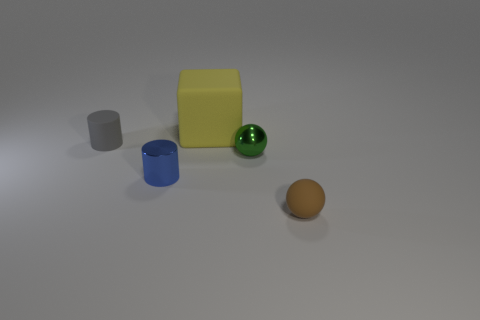Add 4 brown metallic cylinders. How many objects exist? 9 Subtract all balls. How many objects are left? 3 Add 3 gray objects. How many gray objects are left? 4 Add 2 big cubes. How many big cubes exist? 3 Subtract 1 blue cylinders. How many objects are left? 4 Subtract all small red shiny objects. Subtract all large yellow cubes. How many objects are left? 4 